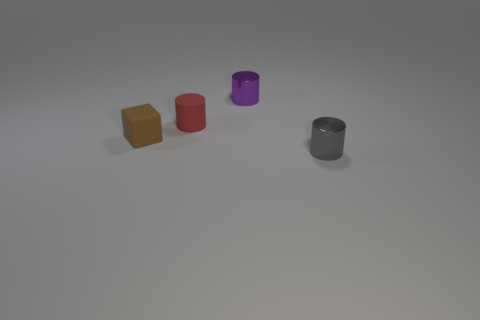Add 3 purple matte spheres. How many objects exist? 7 Subtract all blocks. How many objects are left? 3 Add 2 small purple things. How many small purple things exist? 3 Subtract 0 cyan cubes. How many objects are left? 4 Subtract all small red things. Subtract all big brown balls. How many objects are left? 3 Add 4 brown objects. How many brown objects are left? 5 